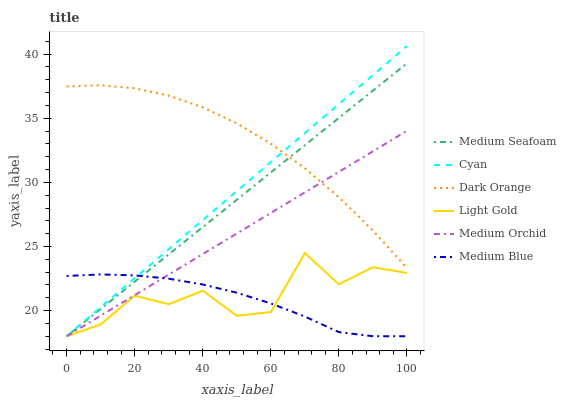Does Medium Orchid have the minimum area under the curve?
Answer yes or no. No. Does Medium Orchid have the maximum area under the curve?
Answer yes or no. No. Is Medium Blue the smoothest?
Answer yes or no. No. Is Medium Blue the roughest?
Answer yes or no. No. Does Medium Orchid have the highest value?
Answer yes or no. No. Is Light Gold less than Dark Orange?
Answer yes or no. Yes. Is Dark Orange greater than Medium Blue?
Answer yes or no. Yes. Does Light Gold intersect Dark Orange?
Answer yes or no. No. 